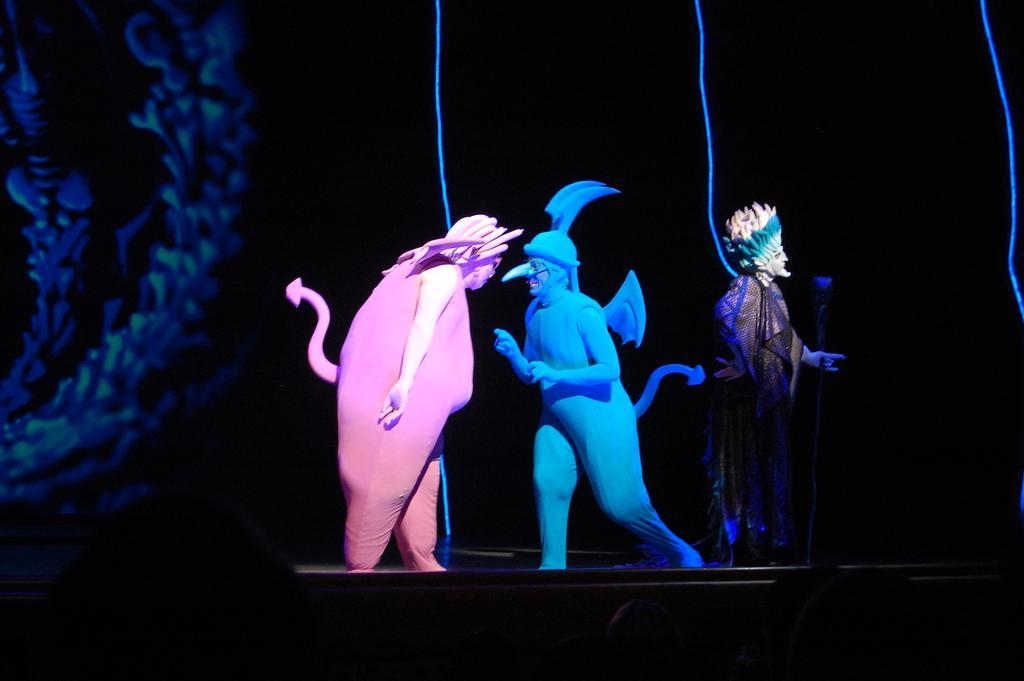In one or two sentences, can you explain what this image depicts? In this image, there are three people standing with fancy dresses. I can see the blue ropes hanging. The background looks dark. On the left side of the image, I can see a design. 